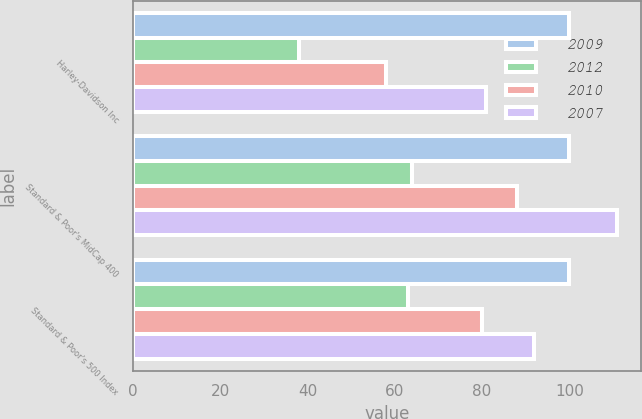Convert chart. <chart><loc_0><loc_0><loc_500><loc_500><stacked_bar_chart><ecel><fcel>Harley-Davidson Inc<fcel>Standard & Poor's MidCap 400<fcel>Standard & Poor's 500 Index<nl><fcel>2009<fcel>100<fcel>100<fcel>100<nl><fcel>2012<fcel>38<fcel>64<fcel>63<nl><fcel>2010<fcel>58<fcel>88<fcel>80<nl><fcel>2007<fcel>81<fcel>111<fcel>92<nl></chart> 